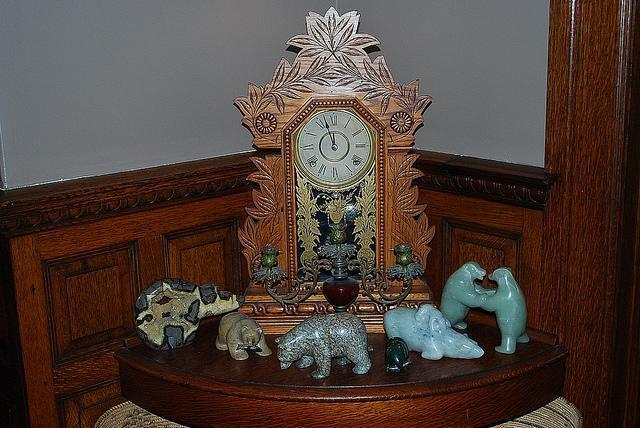How many items are pictured in front of the clock?
Give a very brief answer. 6. How many bears are in the picture?
Give a very brief answer. 1. 